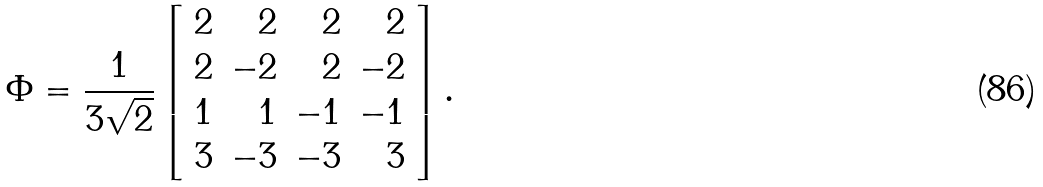Convert formula to latex. <formula><loc_0><loc_0><loc_500><loc_500>\Phi = \frac { 1 } { 3 \sqrt { 2 } } \left [ \begin{array} { r r r r } 2 & 2 & 2 & 2 \\ 2 & - 2 & 2 & - 2 \\ 1 & 1 & - 1 & - 1 \\ 3 & - 3 & - 3 & 3 \end{array} \right ] .</formula> 